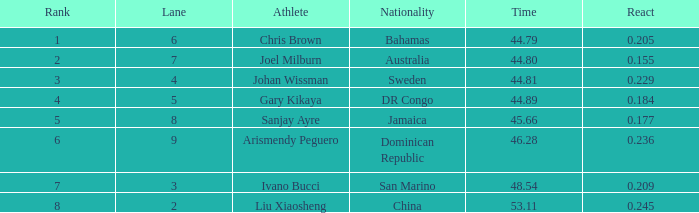209 react entry and a rank higher than 7? 0.0. 